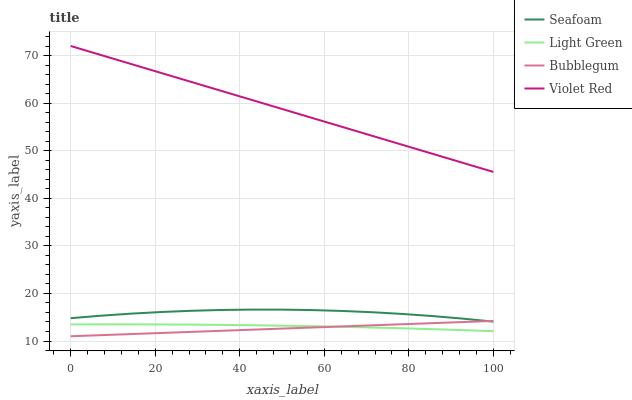Does Seafoam have the minimum area under the curve?
Answer yes or no. No. Does Seafoam have the maximum area under the curve?
Answer yes or no. No. Is Seafoam the smoothest?
Answer yes or no. No. Is Bubblegum the roughest?
Answer yes or no. No. Does Seafoam have the lowest value?
Answer yes or no. No. Does Bubblegum have the highest value?
Answer yes or no. No. Is Seafoam less than Violet Red?
Answer yes or no. Yes. Is Violet Red greater than Seafoam?
Answer yes or no. Yes. Does Seafoam intersect Violet Red?
Answer yes or no. No. 